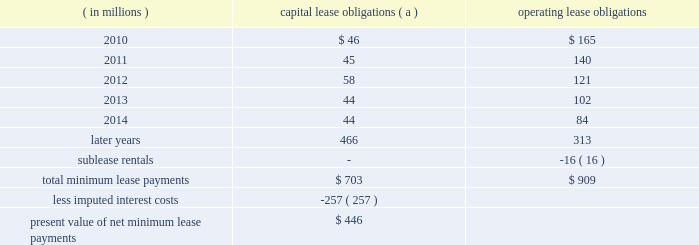Marathon oil corporation notes to consolidated financial statements equivalent to the exchangeable shares at the acquisition date as discussed below .
Additional shares of voting preferred stock will be issued as necessary to adjust the number of votes to account for changes in the exchange ratio .
Preferred shares 2013 in connection with the acquisition of western discussed in note 6 , the board of directors authorized a class of voting preferred stock consisting of 6 million shares .
Upon completion of the acquisition , we issued 5 million shares of this voting preferred stock to a trustee , who holds the shares for the benefit of the holders of the exchangeable shares discussed above .
Each share of voting preferred stock is entitled to one vote on all matters submitted to the holders of marathon common stock .
Each holder of exchangeable shares may direct the trustee to vote the number of shares of voting preferred stock equal to the number of shares of marathon common stock issuable upon the exchange of the exchangeable shares held by that holder .
In no event will the aggregate number of votes entitled to be cast by the trustee with respect to the outstanding shares of voting preferred stock exceed the number of votes entitled to be cast with respect to the outstanding exchangeable shares .
Except as otherwise provided in our restated certificate of incorporation or by applicable law , the common stock and the voting preferred stock will vote together as a single class in the election of directors of marathon and on all other matters submitted to a vote of stockholders of marathon generally .
The voting preferred stock will have no other voting rights except as required by law .
Other than dividends payable solely in shares of voting preferred stock , no dividend or other distribution , will be paid or payable to the holder of the voting preferred stock .
In the event of any liquidation , dissolution or winding up of marathon , the holder of shares of the voting preferred stock will not be entitled to receive any assets of marathon available for distribution to its stockholders .
The voting preferred stock is not convertible into any other class or series of the capital stock of marathon or into cash , property or other rights , and may not be redeemed .
25 .
Leases we lease a wide variety of facilities and equipment under operating leases , including land and building space , office equipment , production facilities and transportation equipment .
Most long-term leases include renewal options and , in certain leases , purchase options .
Future minimum commitments for capital lease obligations ( including sale-leasebacks accounted for as financings ) and for operating lease obligations having initial or remaining noncancelable lease terms in excess of one year are as follows : ( in millions ) capital lease obligations ( a ) operating obligations .
( a ) capital lease obligations include $ 164 million related to assets under construction as of december 31 , 2009 .
These leases are currently reported in long-term debt based on percentage of construction completed at $ 36 million .
In connection with past sales of various plants and operations , we assigned and the purchasers assumed certain leases of major equipment used in the divested plants and operations of united states steel .
In the event of a default by any of the purchasers , united states steel has assumed these obligations ; however , we remain primarily obligated for payments under these leases .
Minimum lease payments under these operating lease obligations of $ 16 million have been included above and an equal amount has been reported as sublease rentals. .
How much of total minimum lease payments ( in millions ) are not due to assets under construction? 
Computations: (703 - 164)
Answer: 539.0. 